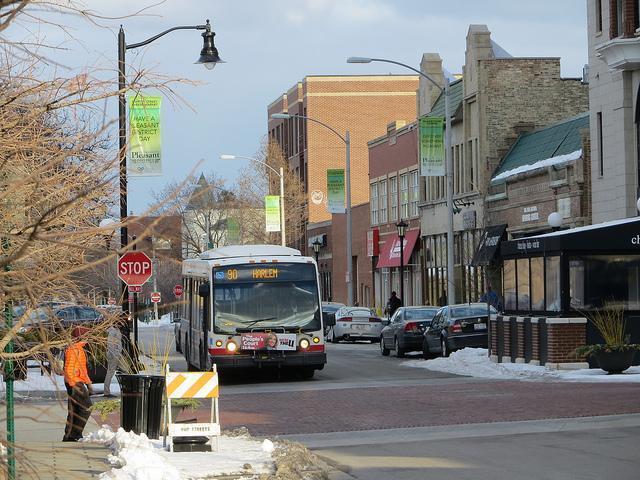Where is the bus headed to?
Answer the question by selecting the correct answer among the 4 following choices.
Options: Harlem, library, mall, trenton. Harlem. 